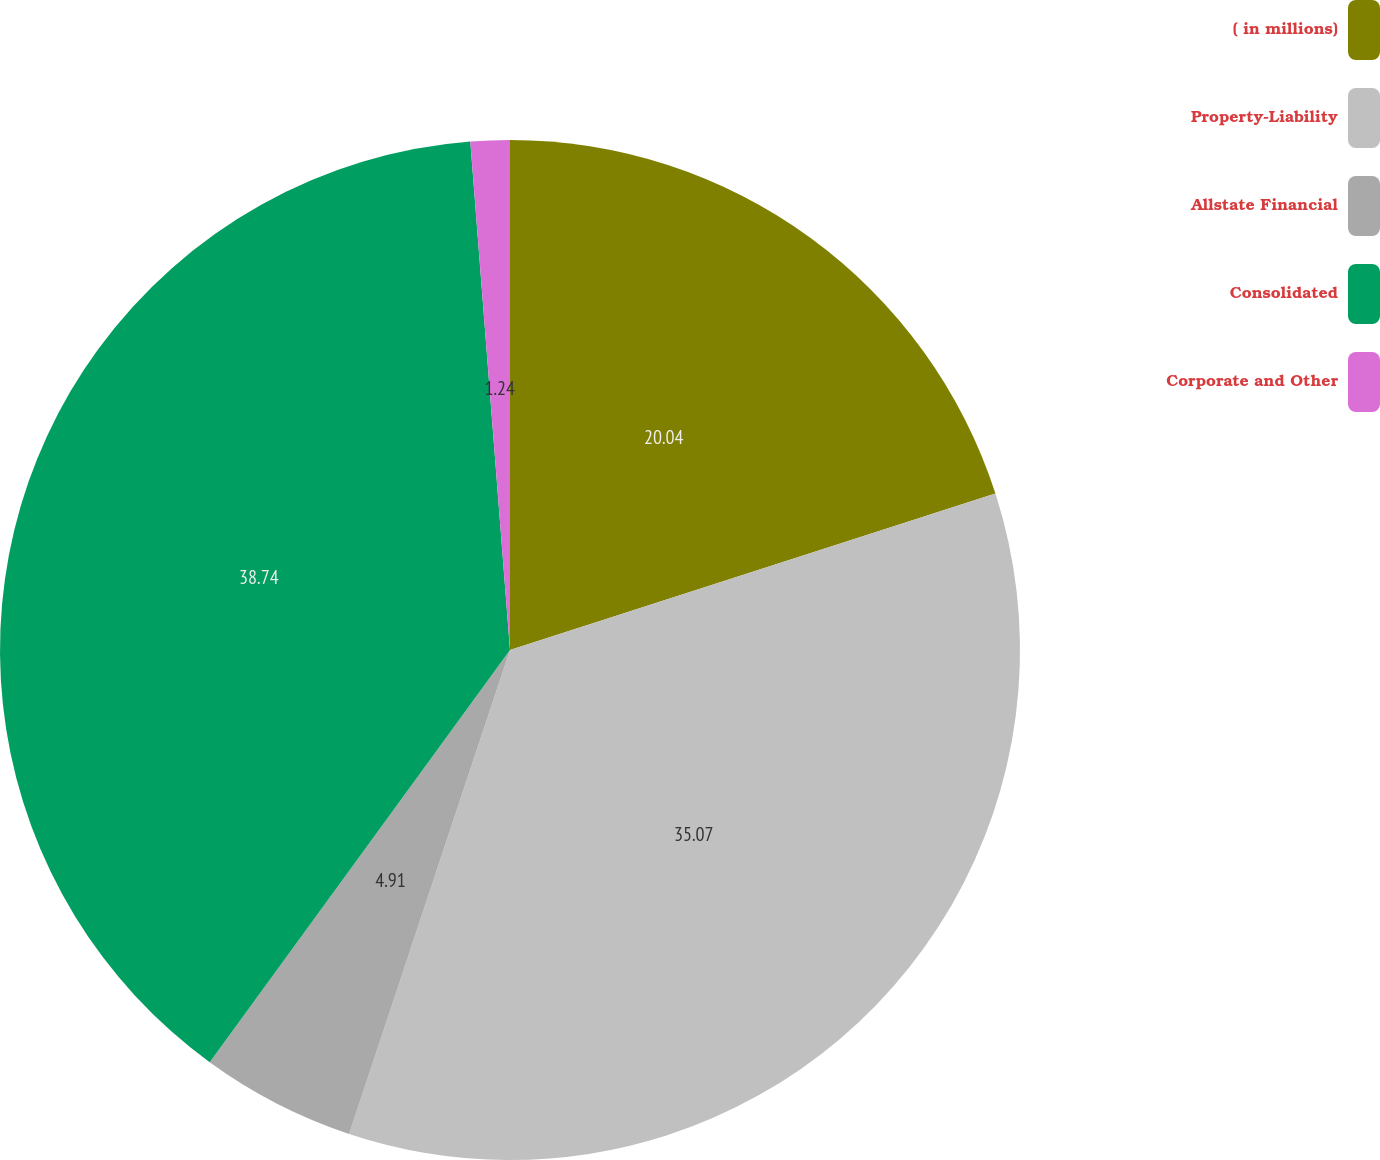Convert chart to OTSL. <chart><loc_0><loc_0><loc_500><loc_500><pie_chart><fcel>( in millions)<fcel>Property-Liability<fcel>Allstate Financial<fcel>Consolidated<fcel>Corporate and Other<nl><fcel>20.04%<fcel>35.07%<fcel>4.91%<fcel>38.74%<fcel>1.24%<nl></chart> 